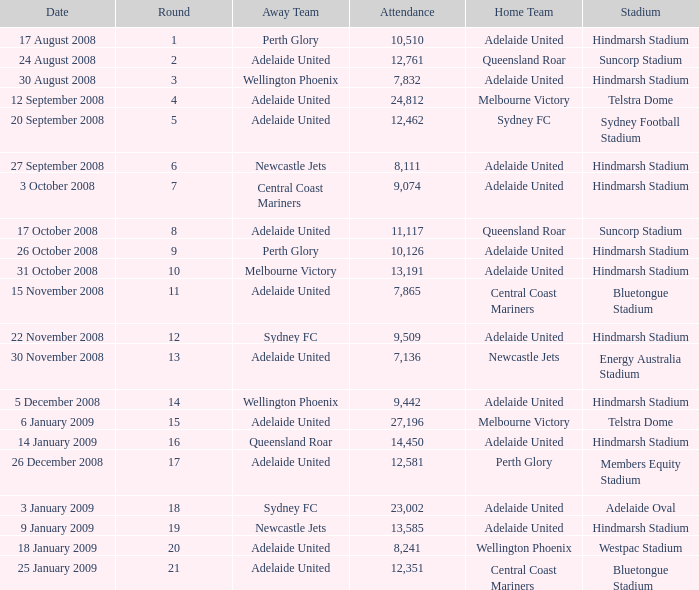What is the round when 11,117 people attended the game on 26 October 2008? 9.0. 